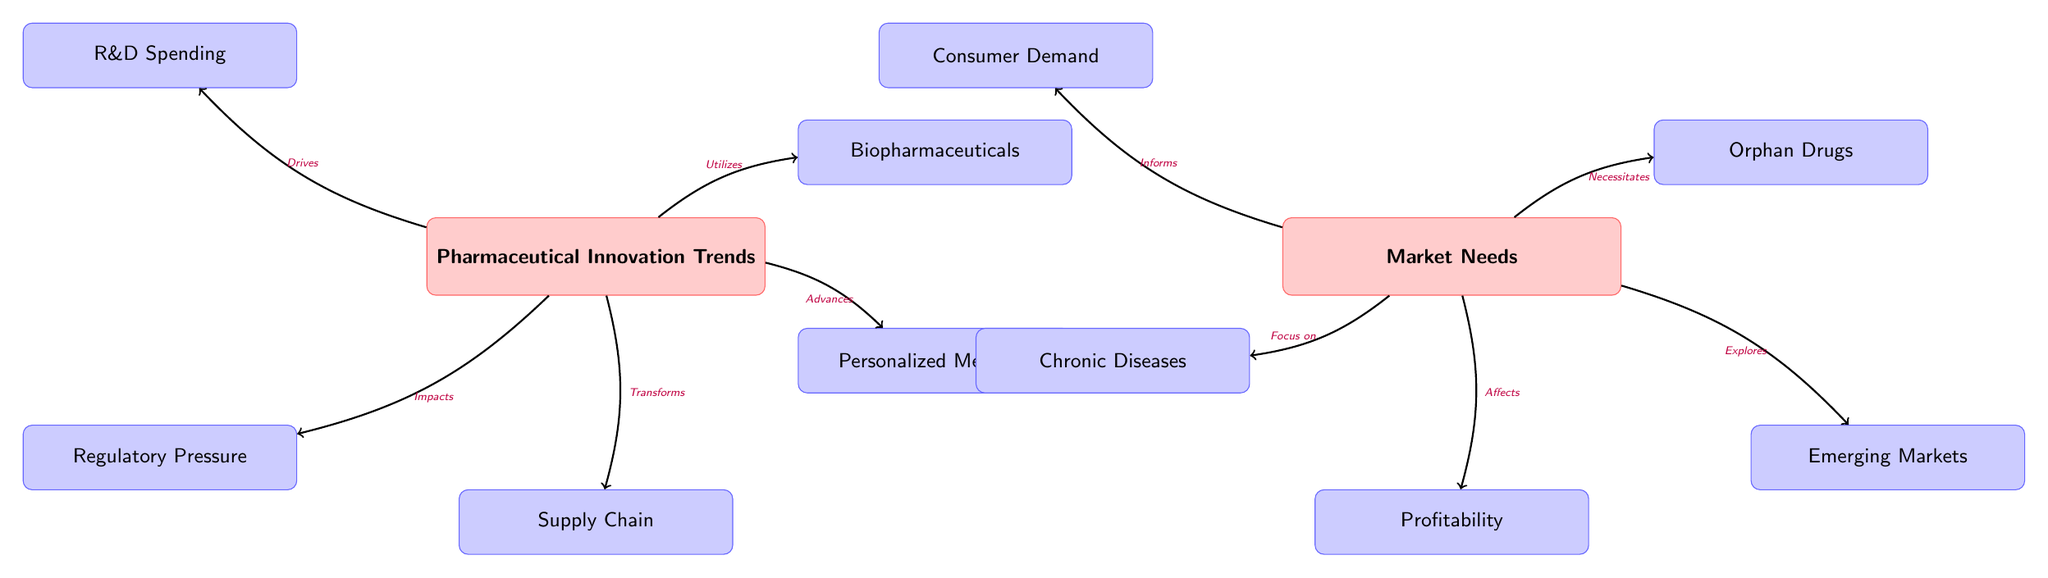What are the main trends in pharmaceutical innovation depicted in the diagram? The main trends depicted are R&D Spending, Regulatory Pressure, Biopharmaceuticals, Personalized Medicine, and Supply Chain. These nodes are directly connected to the main node "Pharmaceutical Innovation Trends," indicating their role as driving factors.
Answer: R&D Spending, Regulatory Pressure, Biopharmaceuticals, Personalized Medicine, Supply Chain Which node in the market section is informed by the main node labeled "Market Needs"? The "Consumer Demand" node is the one that is directly informed by the "Market Needs" node, as indicated by the directed edge connecting them.
Answer: Consumer Demand What relationship exists between "Pharmaceutical Innovation Trends" and "Chronic Diseases"? The "Market Needs" node focuses on "Chronic Diseases," meaning that the market demand specifically addresses the needs associated with chronic conditions, although chronic diseases are not directly linked to innovation trends in this diagram.
Answer: Focus on How many edges are present in the entire diagram? By counting the arrows (directed edges) that connect nodes in both the innovation and market sections, there are a total of ten edges.
Answer: 10 What is the relationship indicated between "Market Needs" and "Profitability"? The relationship indicated is that "Market Needs" affects "Profitability," as shown by the directed edge connecting these two nodes, suggesting that market demands have an impact on financial outcomes.
Answer: Affects Which trend directly transforms the supply chain in pharmaceutical innovation? The "Pharmaceutical Innovation Trends" node directly transforms the "Supply Chain," as explicitly stated by the directed edge pointing from innovation trends to the supply chain.
Answer: Transforms How do "Emerging Markets" relate to the overall market needs? The "Market Needs" explores "Emerging Markets," indicating that there's a specific focus on newer markets as part of understanding and addressing market demands, shown by the directed edge.
Answer: Explores What aspect of pharmaceutical innovation utilizes biopharmaceuticals? The aspect that utilizes biopharmaceuticals is "Pharmaceutical Innovation Trends," as indicated by the directed edge showing that innovation in pharmaceuticals leverages biopharmaceutical developments.
Answer: Utilizes Which node in the innovation section is directly impacted by regulatory pressures? The node that is directly impacted by regulatory pressure in the innovation section is "Regulatory Pressure," which is connected to "Pharmaceutical Innovation Trends" showing a direct influence.
Answer: Impacts 